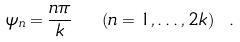<formula> <loc_0><loc_0><loc_500><loc_500>\psi _ { n } = \frac { n \pi } { k } \ \ ( n = 1 , \dots , 2 k ) \ .</formula> 